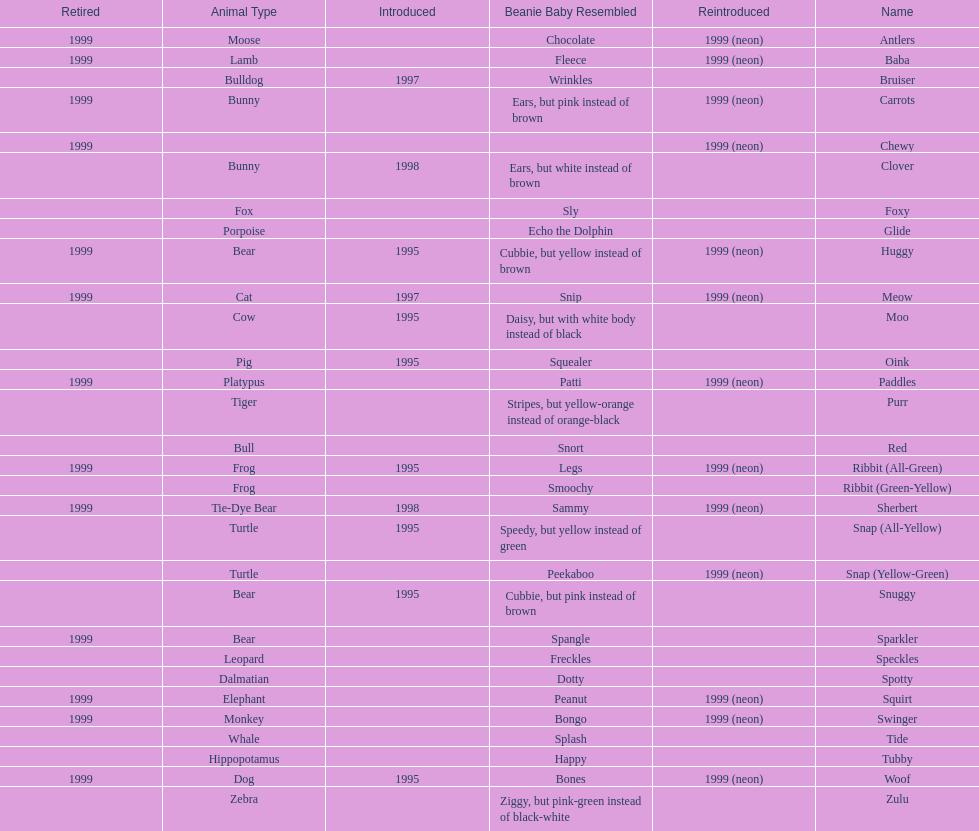What is the total number of pillow pals that were reintroduced as a neon variety? 13. 